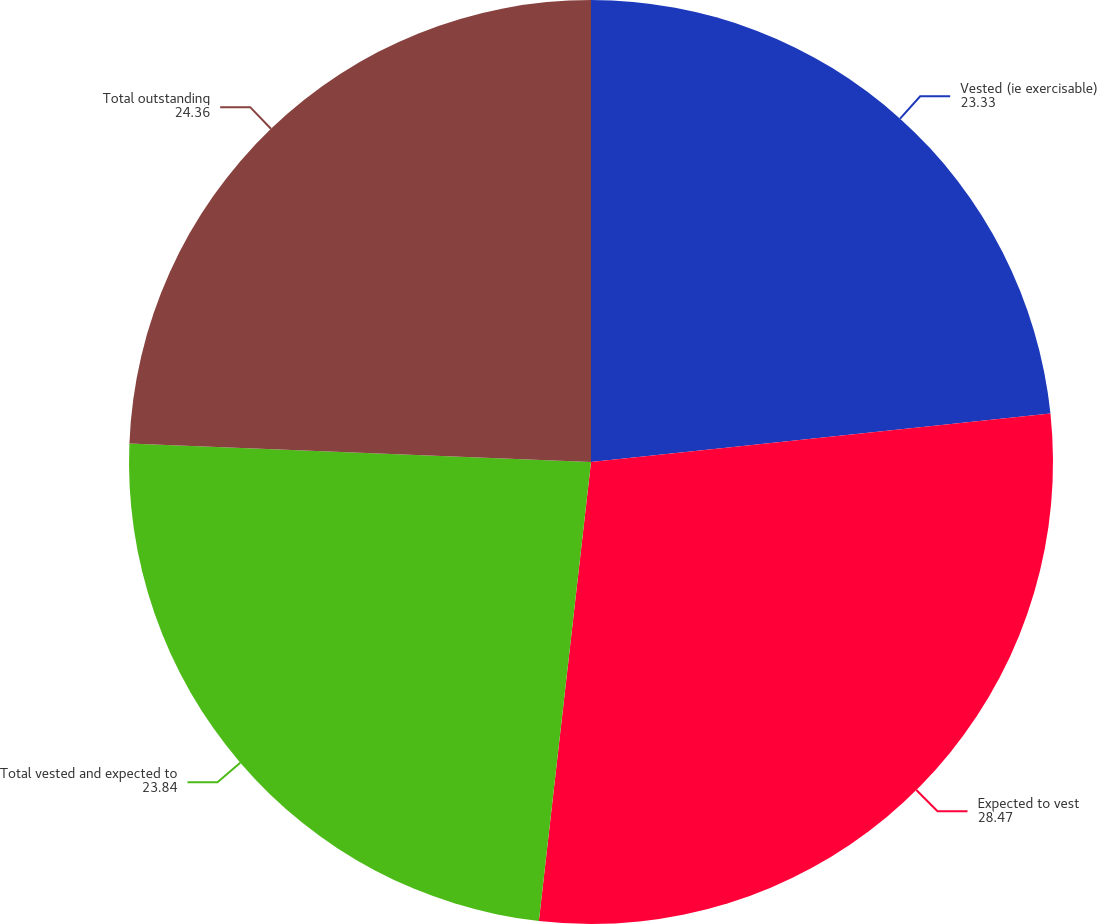Convert chart to OTSL. <chart><loc_0><loc_0><loc_500><loc_500><pie_chart><fcel>Vested (ie exercisable)<fcel>Expected to vest<fcel>Total vested and expected to<fcel>Total outstanding<nl><fcel>23.33%<fcel>28.47%<fcel>23.84%<fcel>24.36%<nl></chart> 